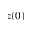<formula> <loc_0><loc_0><loc_500><loc_500>z ( 0 )</formula> 